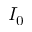<formula> <loc_0><loc_0><loc_500><loc_500>I _ { 0 }</formula> 